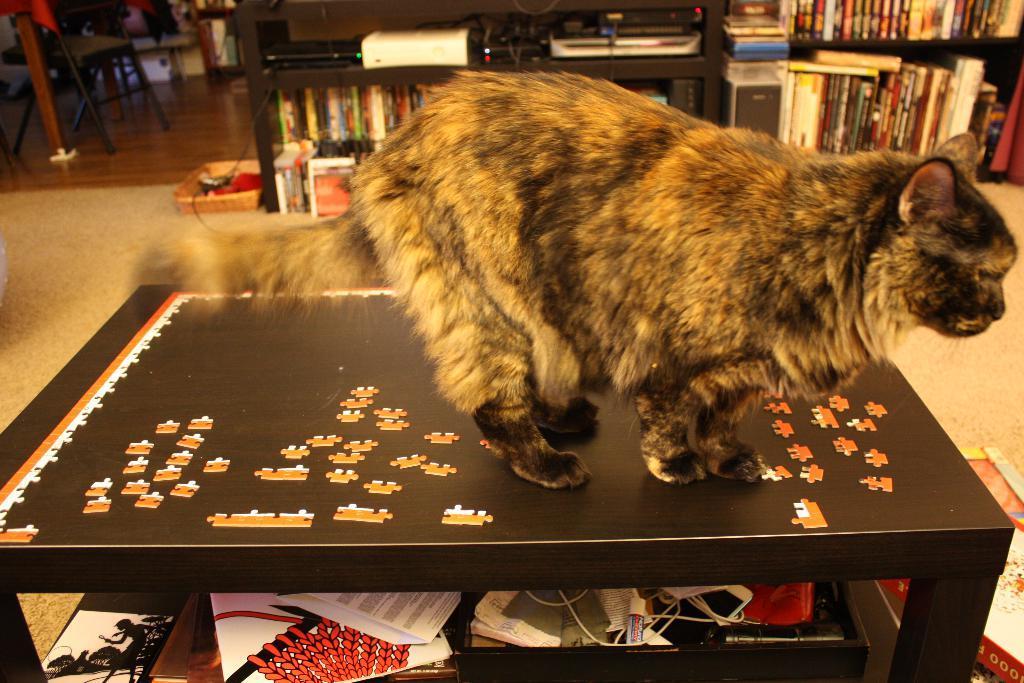Please provide a concise description of this image. In this picture we can see a cat on the table, books on shelves, devices, cables, basket, chair on the floor and some objects. 